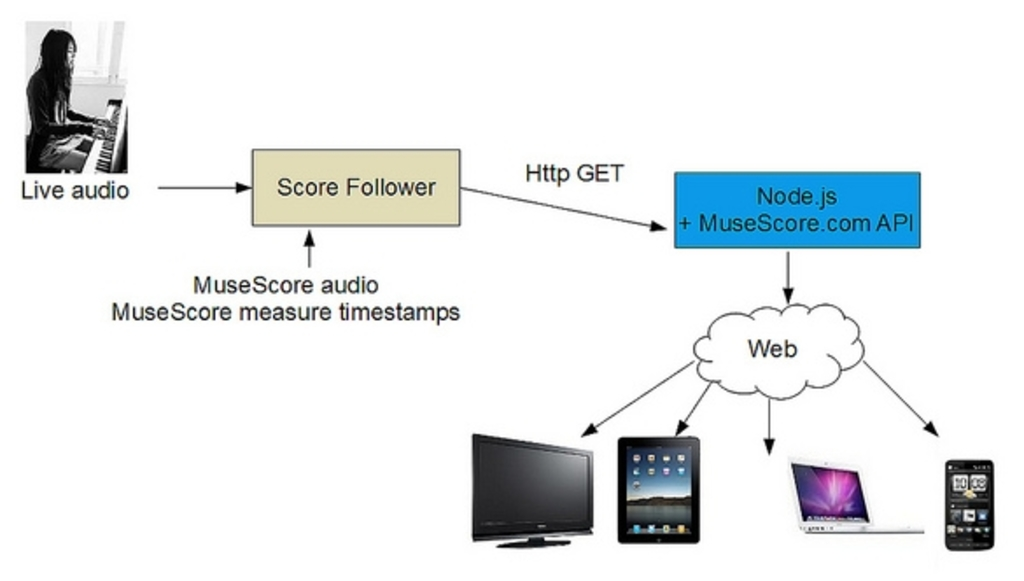What potential improvements or alternatives could be considered for the current audio distribution method shown in the chart? An alternative to improve the system could include incorporating advanced audio processing algorithms that provide noise cancellation and audio enhancement before it reaches the Score Follower. Additionally, using WebSocket for real-time data transfer instead of HTTP GET might reduce latency, enhancing the synchronicity between live performances and digital outputs. Finally, integrating AI-driven analytics could offer insights into user engagement and performance proficiency, potentially driving a more personalized user experience. 